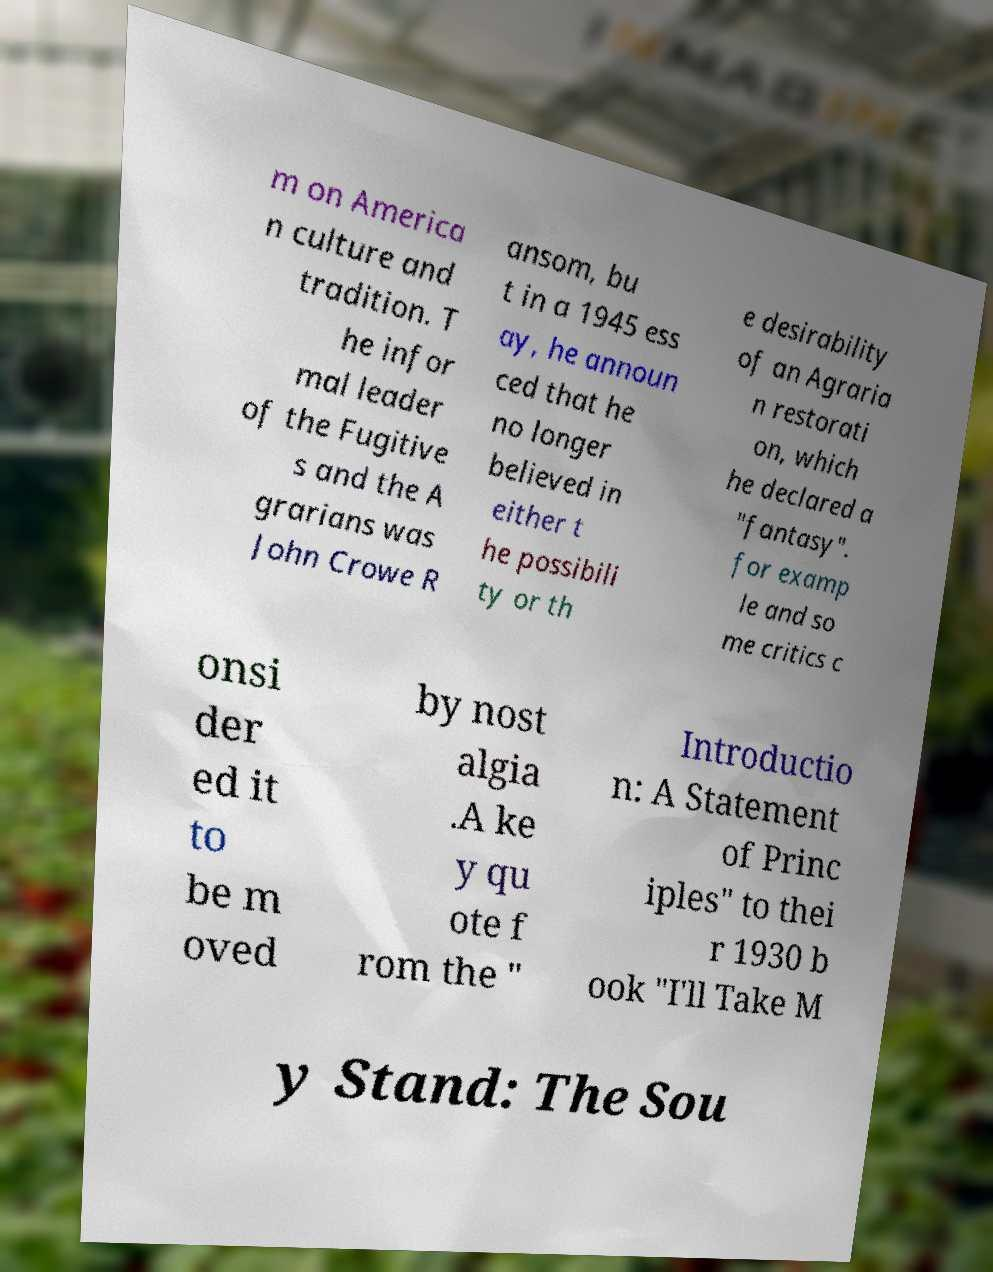I need the written content from this picture converted into text. Can you do that? m on America n culture and tradition. T he infor mal leader of the Fugitive s and the A grarians was John Crowe R ansom, bu t in a 1945 ess ay, he announ ced that he no longer believed in either t he possibili ty or th e desirability of an Agraria n restorati on, which he declared a "fantasy". for examp le and so me critics c onsi der ed it to be m oved by nost algia .A ke y qu ote f rom the " Introductio n: A Statement of Princ iples" to thei r 1930 b ook "I'll Take M y Stand: The Sou 